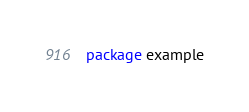<code> <loc_0><loc_0><loc_500><loc_500><_Go_>package example
</code> 